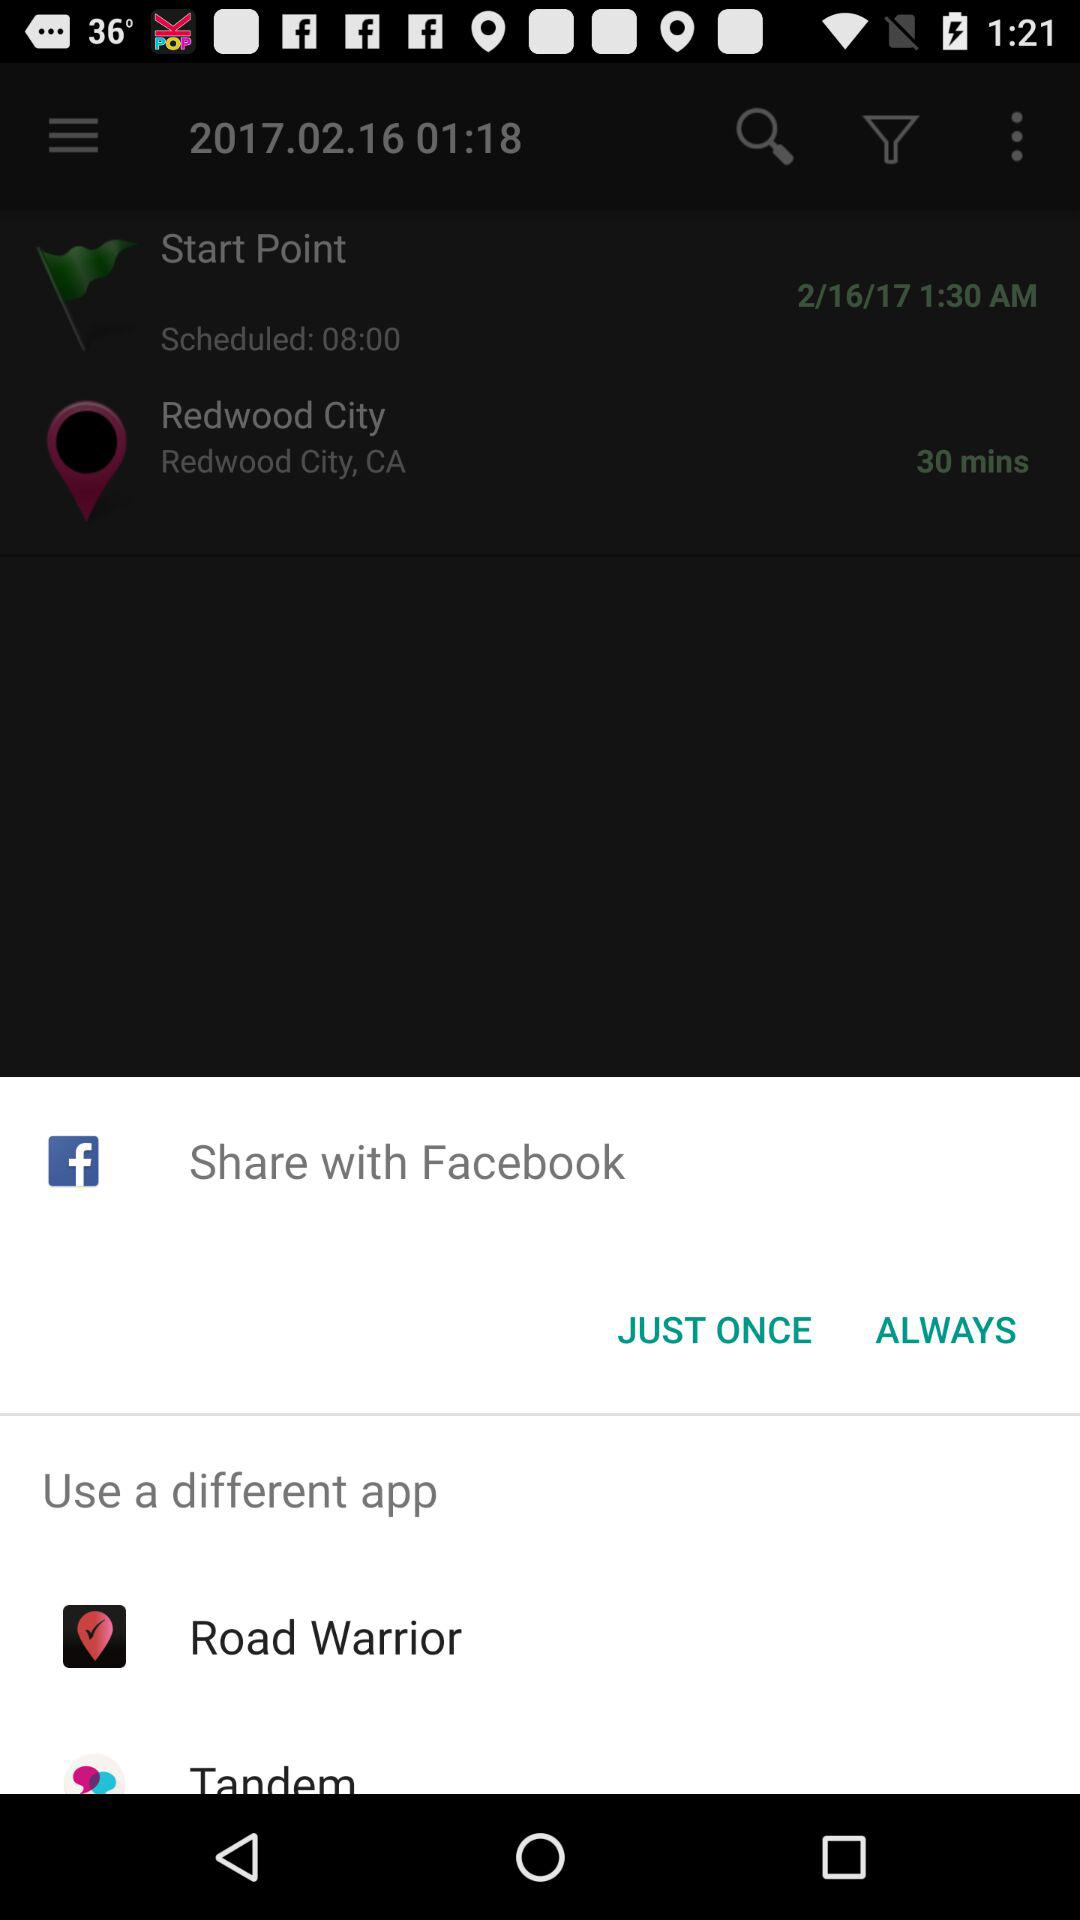Through which account can content be shared? Content can be shared through "Facebook", "Road Warrior" and "Tandem" accounts. 